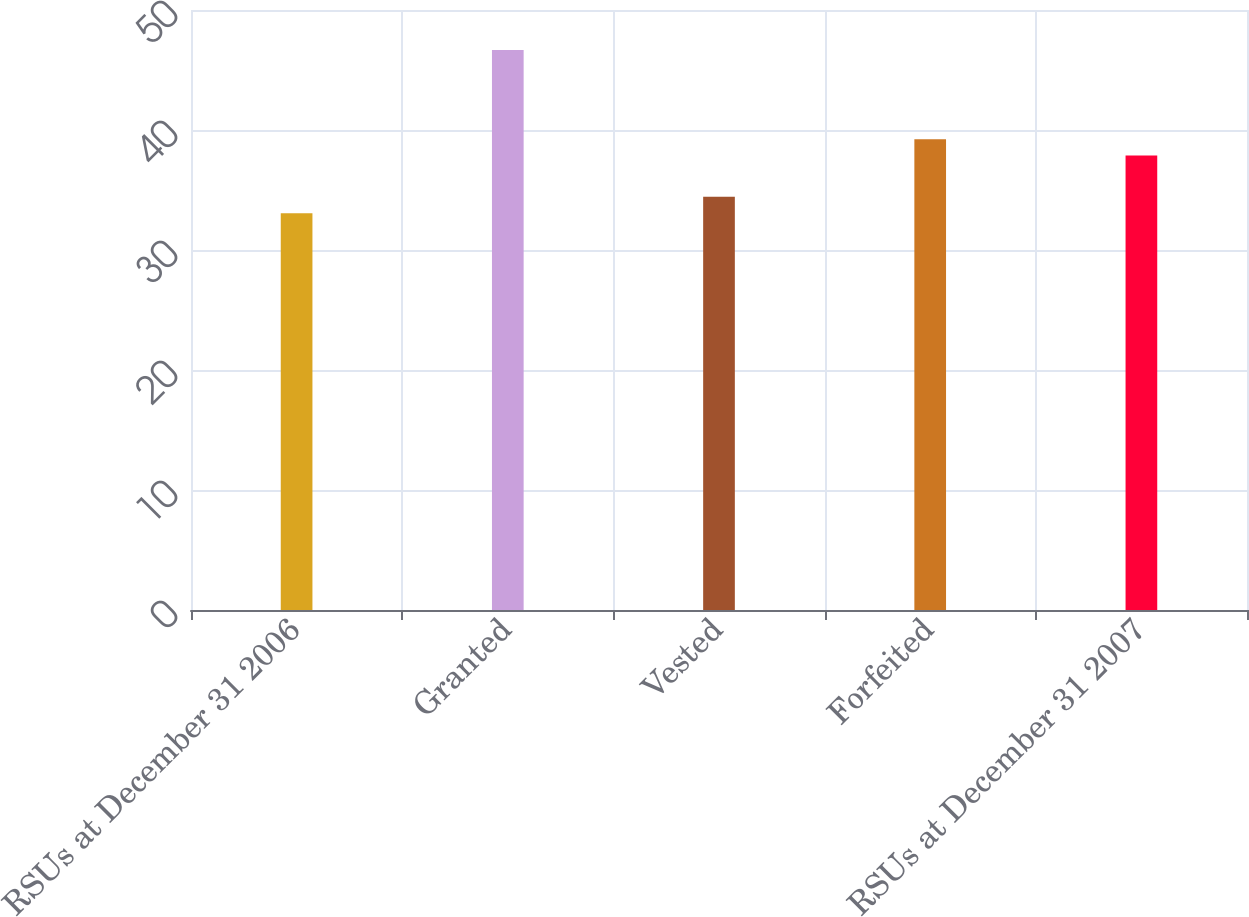Convert chart to OTSL. <chart><loc_0><loc_0><loc_500><loc_500><bar_chart><fcel>RSUs at December 31 2006<fcel>Granted<fcel>Vested<fcel>Forfeited<fcel>RSUs at December 31 2007<nl><fcel>33.07<fcel>46.67<fcel>34.43<fcel>39.23<fcel>37.87<nl></chart> 